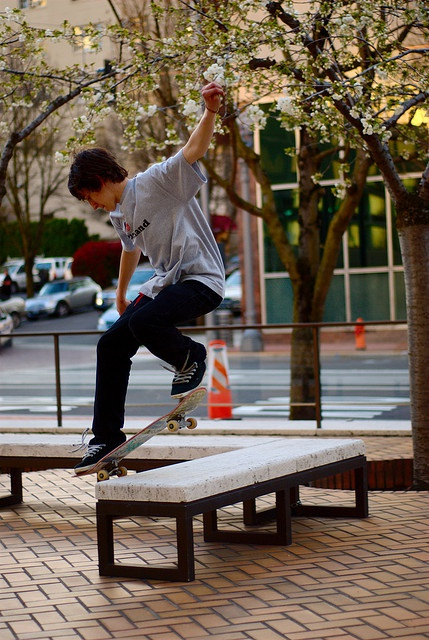Describe the objects in this image and their specific colors. I can see people in tan, black, gray, darkgray, and maroon tones, bench in tan, black, darkgray, lightgray, and gray tones, bench in tan, black, darkgray, and gray tones, skateboard in tan, gray, black, and maroon tones, and car in tan, gray, black, darkgray, and blue tones in this image. 